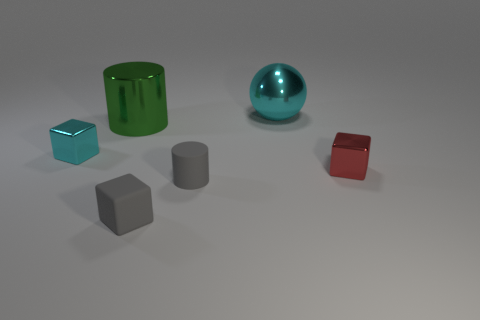Add 3 blocks. How many objects exist? 9 Subtract all cylinders. How many objects are left? 4 Subtract all green cylinders. Subtract all large metallic cylinders. How many objects are left? 4 Add 4 gray matte cylinders. How many gray matte cylinders are left? 5 Add 4 large red metal cylinders. How many large red metal cylinders exist? 4 Subtract 0 yellow cubes. How many objects are left? 6 